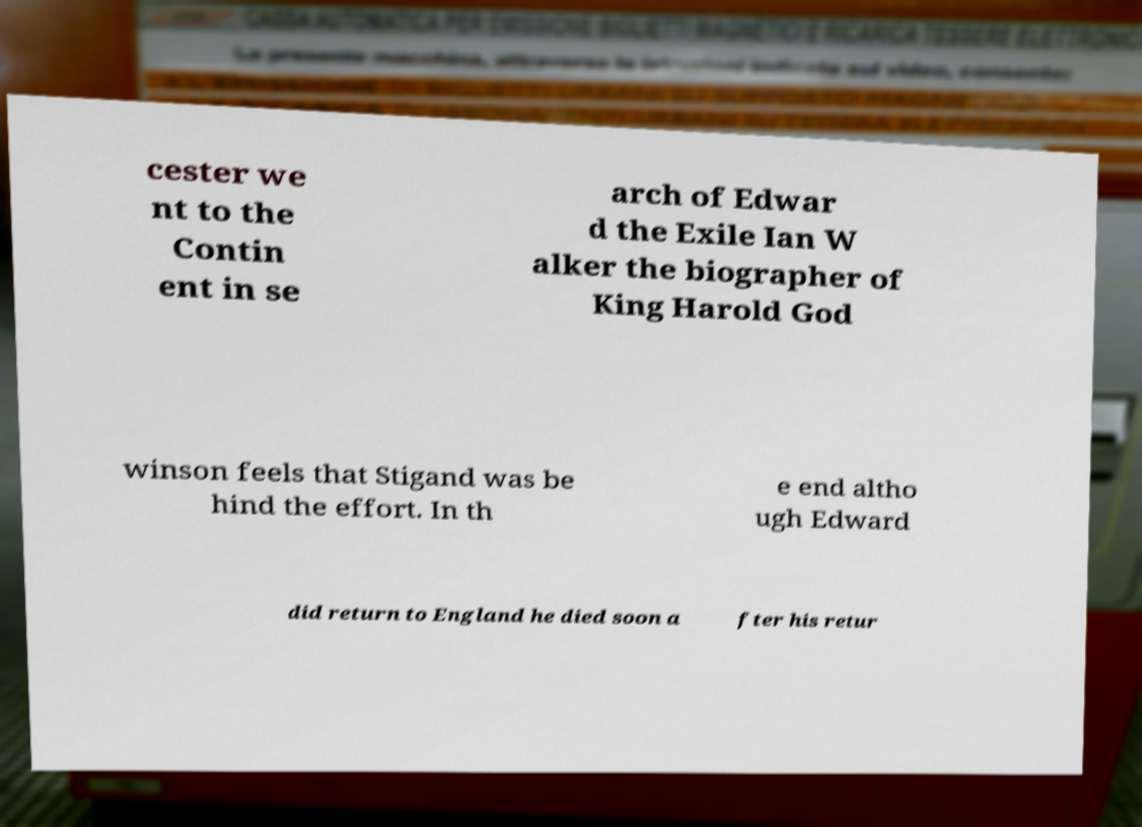Can you read and provide the text displayed in the image?This photo seems to have some interesting text. Can you extract and type it out for me? cester we nt to the Contin ent in se arch of Edwar d the Exile Ian W alker the biographer of King Harold God winson feels that Stigand was be hind the effort. In th e end altho ugh Edward did return to England he died soon a fter his retur 